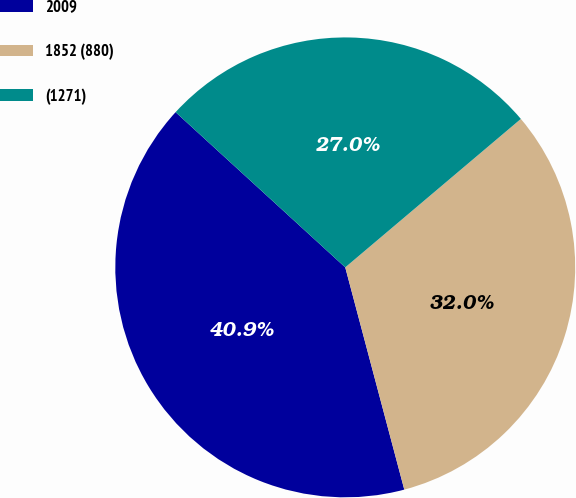Convert chart. <chart><loc_0><loc_0><loc_500><loc_500><pie_chart><fcel>2009<fcel>1852 (880)<fcel>(1271)<nl><fcel>40.93%<fcel>32.04%<fcel>27.04%<nl></chart> 